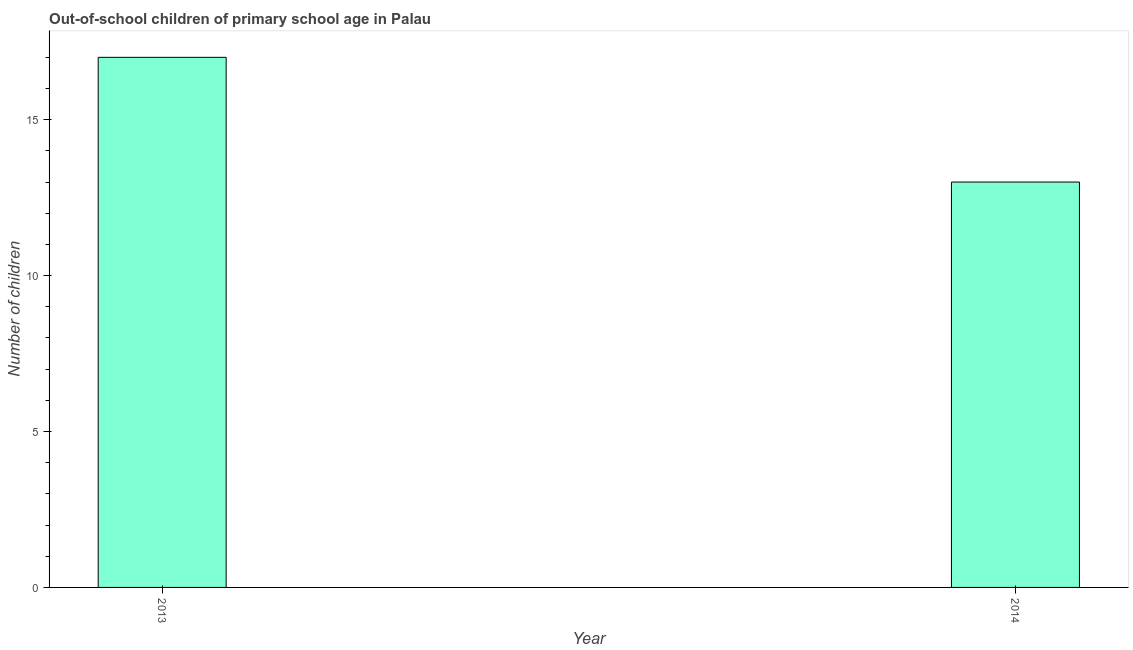Does the graph contain any zero values?
Provide a short and direct response. No. What is the title of the graph?
Offer a terse response. Out-of-school children of primary school age in Palau. What is the label or title of the Y-axis?
Your response must be concise. Number of children. What is the number of out-of-school children in 2014?
Give a very brief answer. 13. Across all years, what is the minimum number of out-of-school children?
Ensure brevity in your answer.  13. In which year was the number of out-of-school children maximum?
Provide a short and direct response. 2013. In which year was the number of out-of-school children minimum?
Provide a short and direct response. 2014. What is the sum of the number of out-of-school children?
Your answer should be very brief. 30. What is the median number of out-of-school children?
Offer a terse response. 15. What is the ratio of the number of out-of-school children in 2013 to that in 2014?
Provide a succinct answer. 1.31. In how many years, is the number of out-of-school children greater than the average number of out-of-school children taken over all years?
Provide a short and direct response. 1. What is the difference between two consecutive major ticks on the Y-axis?
Provide a short and direct response. 5. Are the values on the major ticks of Y-axis written in scientific E-notation?
Ensure brevity in your answer.  No. What is the ratio of the Number of children in 2013 to that in 2014?
Provide a short and direct response. 1.31. 